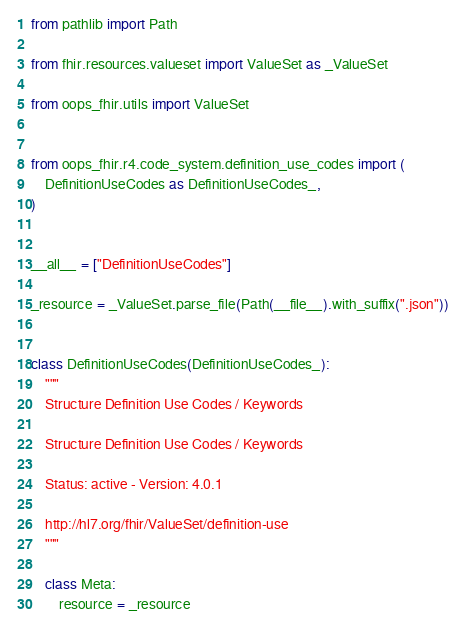<code> <loc_0><loc_0><loc_500><loc_500><_Python_>from pathlib import Path

from fhir.resources.valueset import ValueSet as _ValueSet

from oops_fhir.utils import ValueSet


from oops_fhir.r4.code_system.definition_use_codes import (
    DefinitionUseCodes as DefinitionUseCodes_,
)


__all__ = ["DefinitionUseCodes"]

_resource = _ValueSet.parse_file(Path(__file__).with_suffix(".json"))


class DefinitionUseCodes(DefinitionUseCodes_):
    """
    Structure Definition Use Codes / Keywords

    Structure Definition Use Codes / Keywords

    Status: active - Version: 4.0.1

    http://hl7.org/fhir/ValueSet/definition-use
    """

    class Meta:
        resource = _resource
</code> 